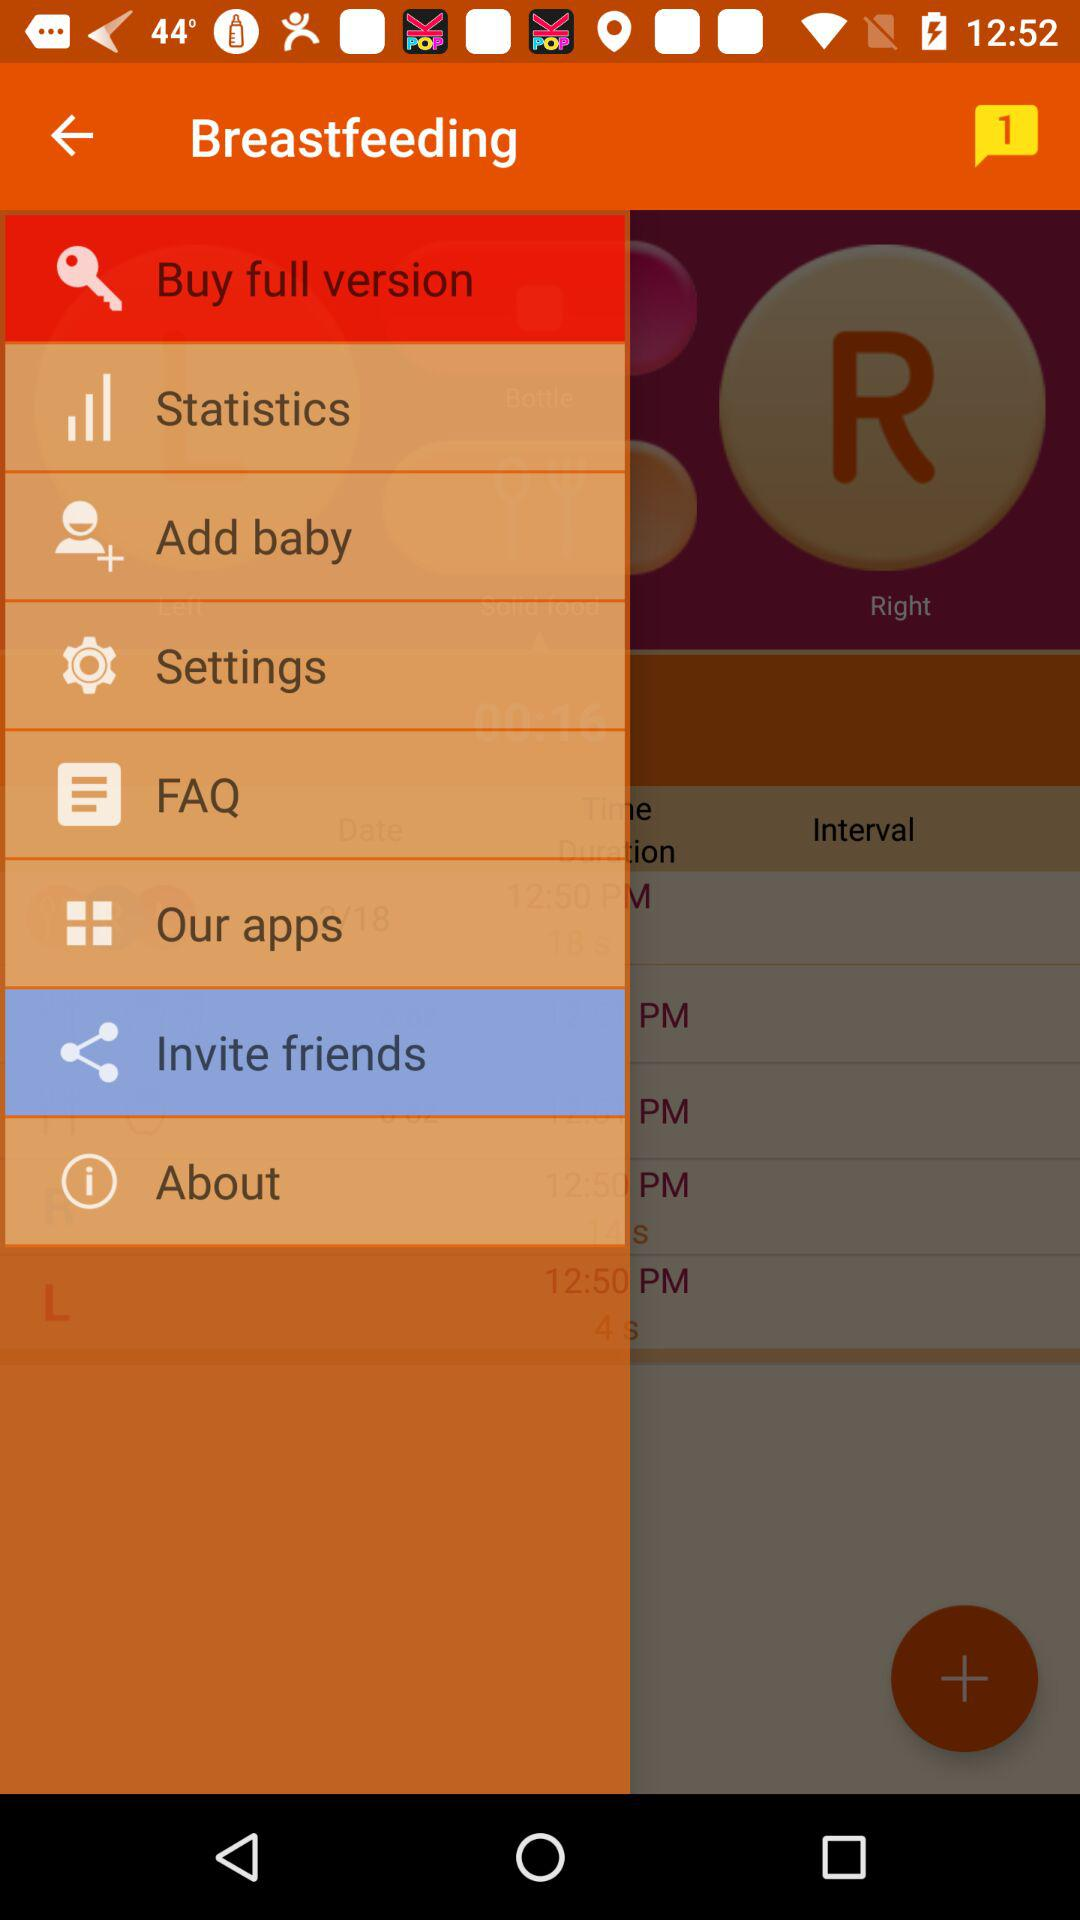What's the number of notifications? The number of notifications is 1. 